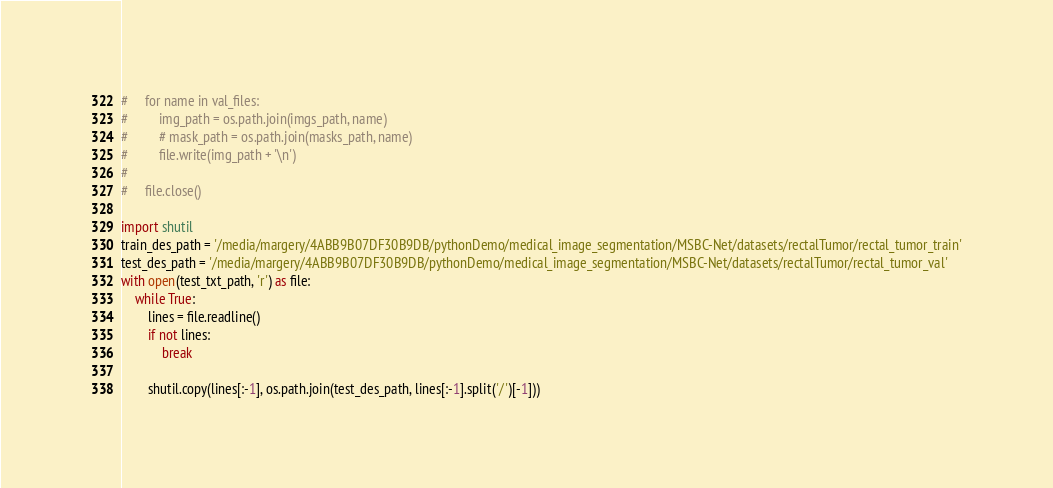<code> <loc_0><loc_0><loc_500><loc_500><_Python_>#     for name in val_files:
#         img_path = os.path.join(imgs_path, name)
#         # mask_path = os.path.join(masks_path, name)
#         file.write(img_path + '\n')
#
#     file.close()

import shutil
train_des_path = '/media/margery/4ABB9B07DF30B9DB/pythonDemo/medical_image_segmentation/MSBC-Net/datasets/rectalTumor/rectal_tumor_train'
test_des_path = '/media/margery/4ABB9B07DF30B9DB/pythonDemo/medical_image_segmentation/MSBC-Net/datasets/rectalTumor/rectal_tumor_val'
with open(test_txt_path, 'r') as file:
    while True:
        lines = file.readline()
        if not lines:
            break

        shutil.copy(lines[:-1], os.path.join(test_des_path, lines[:-1].split('/')[-1]))


</code> 